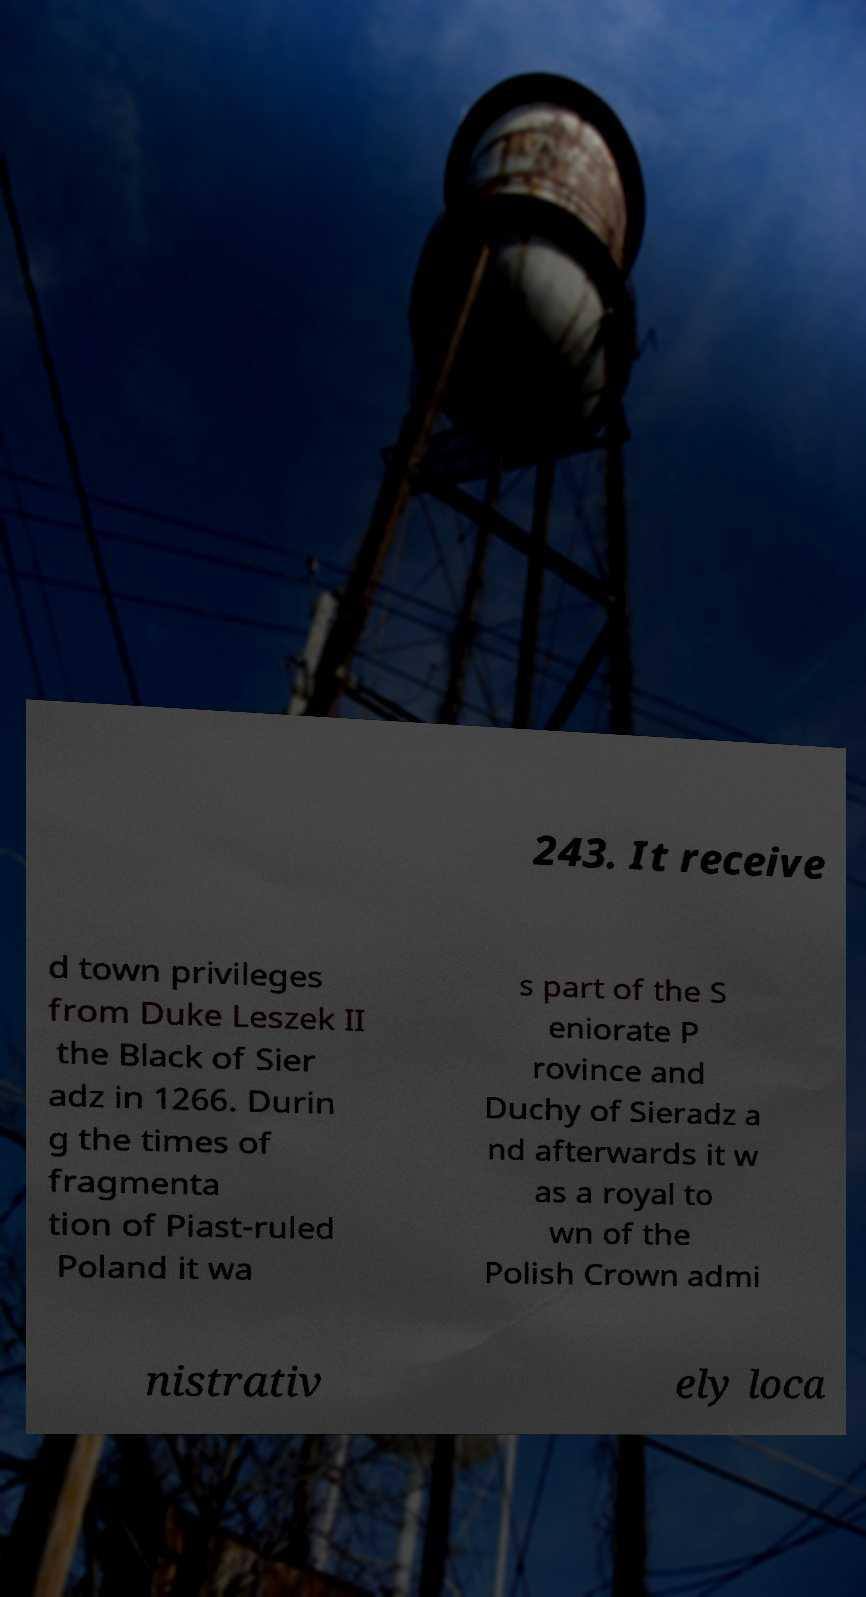Please identify and transcribe the text found in this image. 243. It receive d town privileges from Duke Leszek II the Black of Sier adz in 1266. Durin g the times of fragmenta tion of Piast-ruled Poland it wa s part of the S eniorate P rovince and Duchy of Sieradz a nd afterwards it w as a royal to wn of the Polish Crown admi nistrativ ely loca 